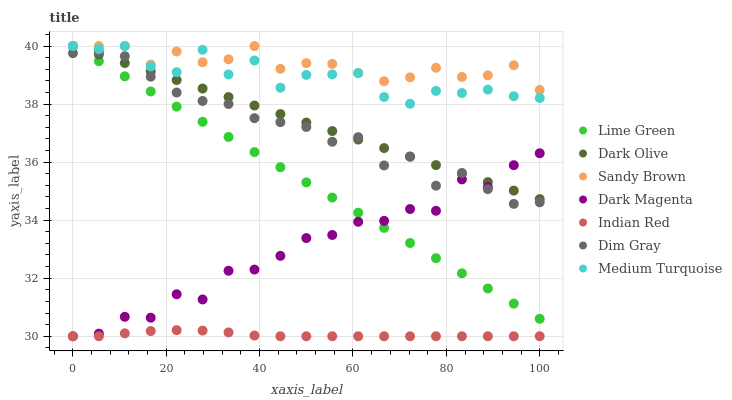Does Indian Red have the minimum area under the curve?
Answer yes or no. Yes. Does Sandy Brown have the maximum area under the curve?
Answer yes or no. Yes. Does Dim Gray have the minimum area under the curve?
Answer yes or no. No. Does Dim Gray have the maximum area under the curve?
Answer yes or no. No. Is Dark Olive the smoothest?
Answer yes or no. Yes. Is Medium Turquoise the roughest?
Answer yes or no. Yes. Is Dim Gray the smoothest?
Answer yes or no. No. Is Dim Gray the roughest?
Answer yes or no. No. Does Dark Magenta have the lowest value?
Answer yes or no. Yes. Does Dim Gray have the lowest value?
Answer yes or no. No. Does Sandy Brown have the highest value?
Answer yes or no. Yes. Does Dim Gray have the highest value?
Answer yes or no. No. Is Indian Red less than Sandy Brown?
Answer yes or no. Yes. Is Sandy Brown greater than Dark Magenta?
Answer yes or no. Yes. Does Dark Olive intersect Medium Turquoise?
Answer yes or no. Yes. Is Dark Olive less than Medium Turquoise?
Answer yes or no. No. Is Dark Olive greater than Medium Turquoise?
Answer yes or no. No. Does Indian Red intersect Sandy Brown?
Answer yes or no. No. 